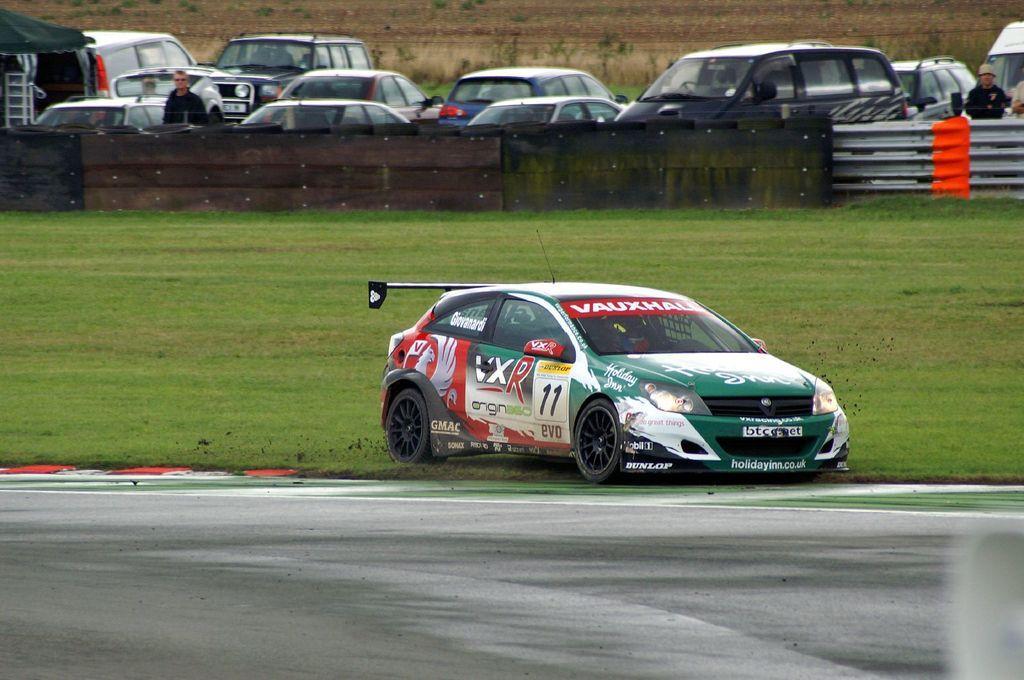Can you describe this image briefly? This picture shows the few cars parked and we see couple of them standing and we see a racing car and grass on the ground and we see a fence and a road. 